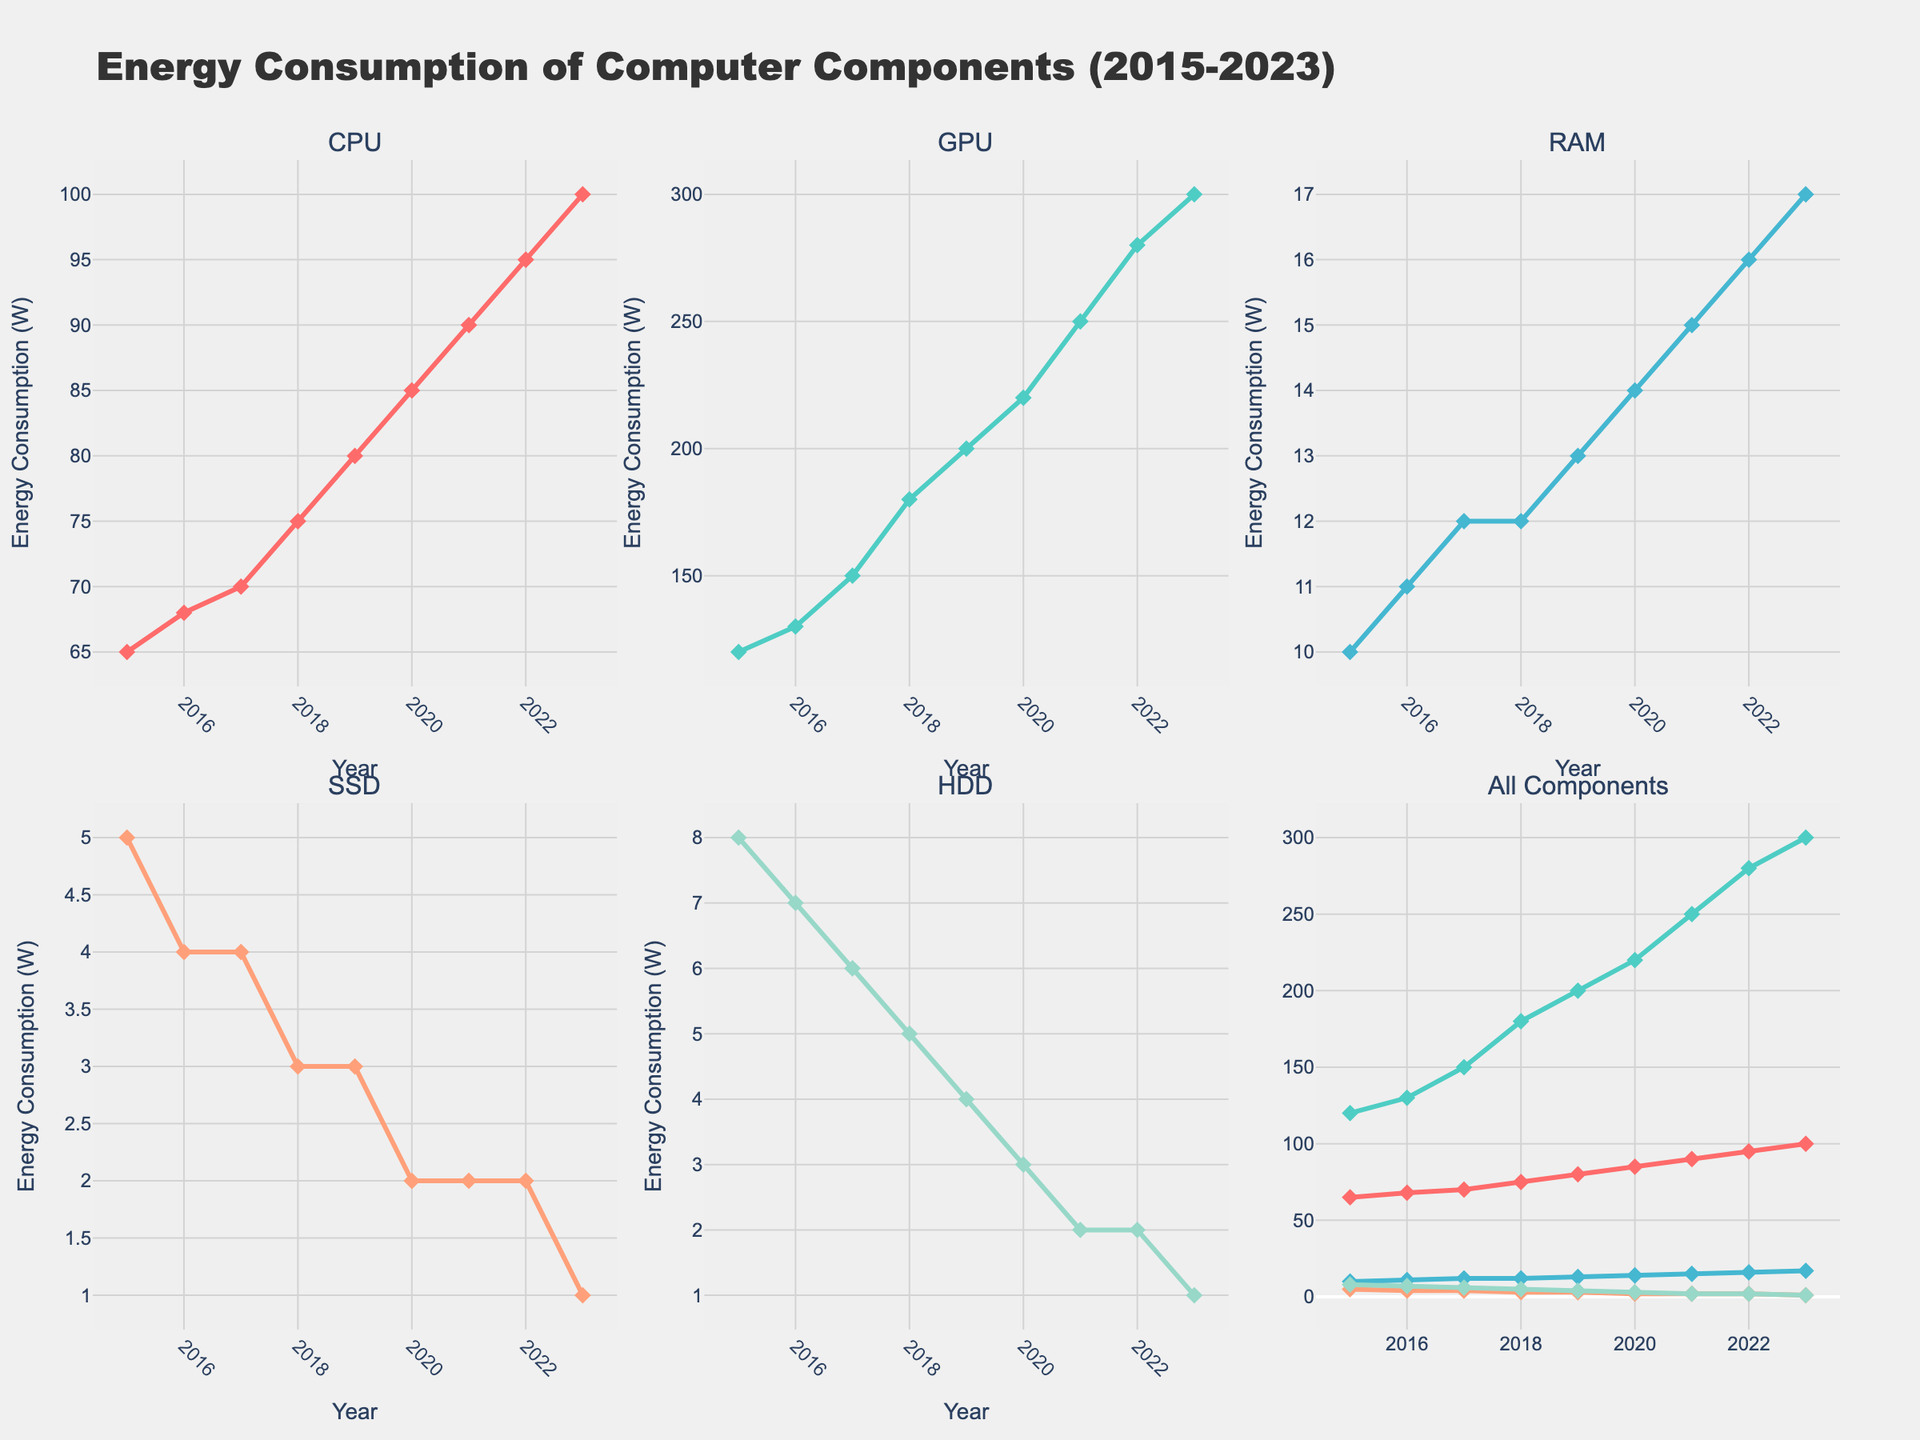What is the total energy consumption of the CPU and GPU in 2020? First, locate the values for the CPU and GPU in 2020: CPU is 85 W and GPU is 220 W. Sum them up: 85 + 220 = 305 W.
Answer: 305 W Which component has the highest energy consumption in 2023? Look at the energy consumption values for all components in 2023. The GPU has the highest value at 300 W.
Answer: GPU How does the energy consumption trend of the SSD compare to that of the RAM between 2015 and 2023? SSD energy consumption decreases from 5 W to 1 W, while RAM energy consumption increases from 10 W to 17 W. One decreases while the other increases.
Answer: SSD decreases; RAM increases What is the average energy consumption of the HDD from 2015 to 2023? Find the values for the HDD over the years: 8, 7, 6, 5, 4, 3, 2, 2, 1. Sum them: 8 + 7 + 6 + 5 + 4 + 3 + 2 + 2 + 1 = 38. Divide by the number of years (9): 38 / 9 ≈ 4.22 W.
Answer: 4.22 W In which year did the GPU's energy consumption first exceed 200 W? Look at the GPU's values to find the first year exceeding 200 W. The value in 2019 is 200 W and in 2020 it is 220 W. So, it first exceeds 200 W in 2020.
Answer: 2020 How much did the RAM's energy consumption increase from 2015 to 2023? Find the values for RAM in 2015 and 2023: 10 W and 17 W. Calculate the difference: 17 - 10 = 7 W.
Answer: 7 W Compare the energy consumption trends of the CPU and GPU between 2015 and 2023. Both CPU and GPU show increasing trends from 2015 to 2023. CPU goes from 65 W to 100 W, and GPU goes from 120 W to 300 W. Both are increasing but GPU increases faster.
Answer: Both increasing; GPU increases faster What is the median energy consumption for the SSD over the given years? Order the SSD values: 1, 2, 2, 3, 3, 4, 4, 5, 5. The middle value (5th value) is 3 W.
Answer: 3 W Which component shows the least variation in energy consumption over the years? Look for the component with the least change in values from 2015 to 2023. SSD ranges from 5 W to 1 W, showing the smallest absolute variation.
Answer: SSD 